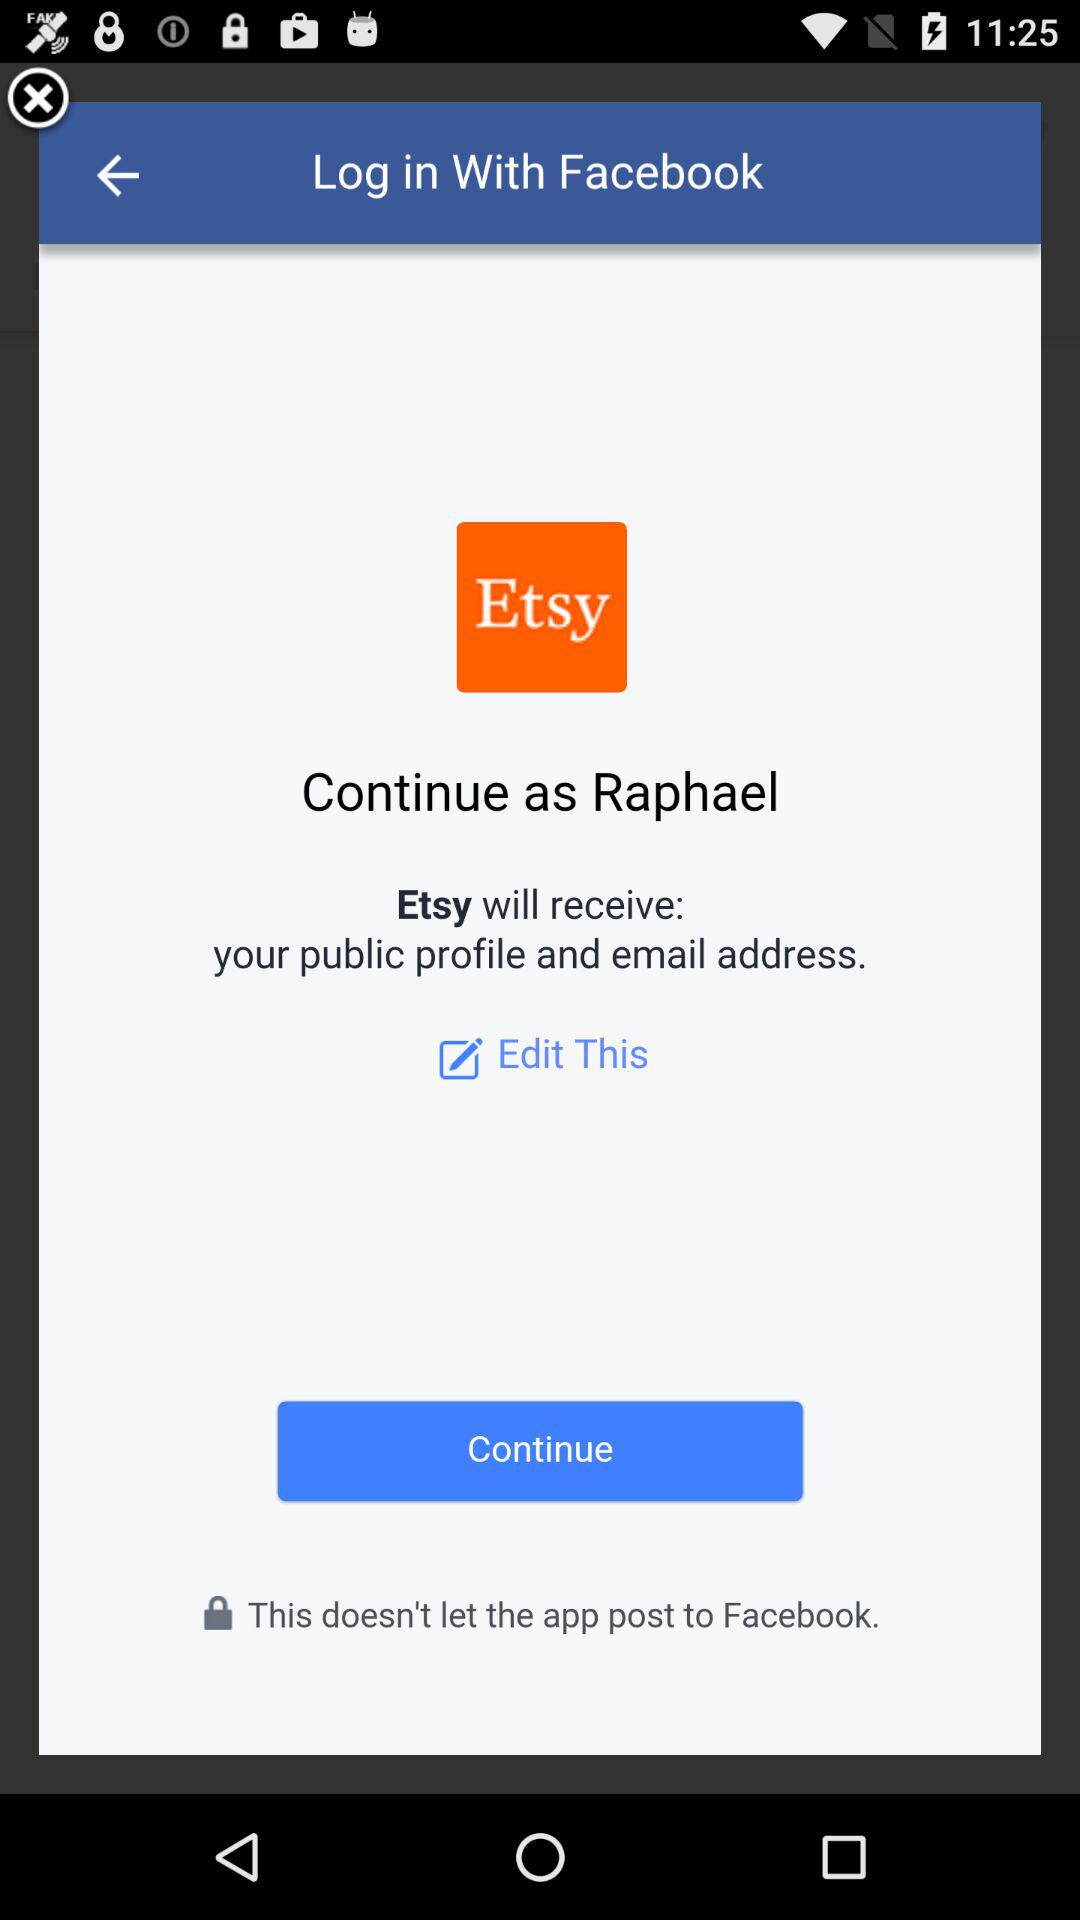What application is asking for permission? The application is "Etsy". 